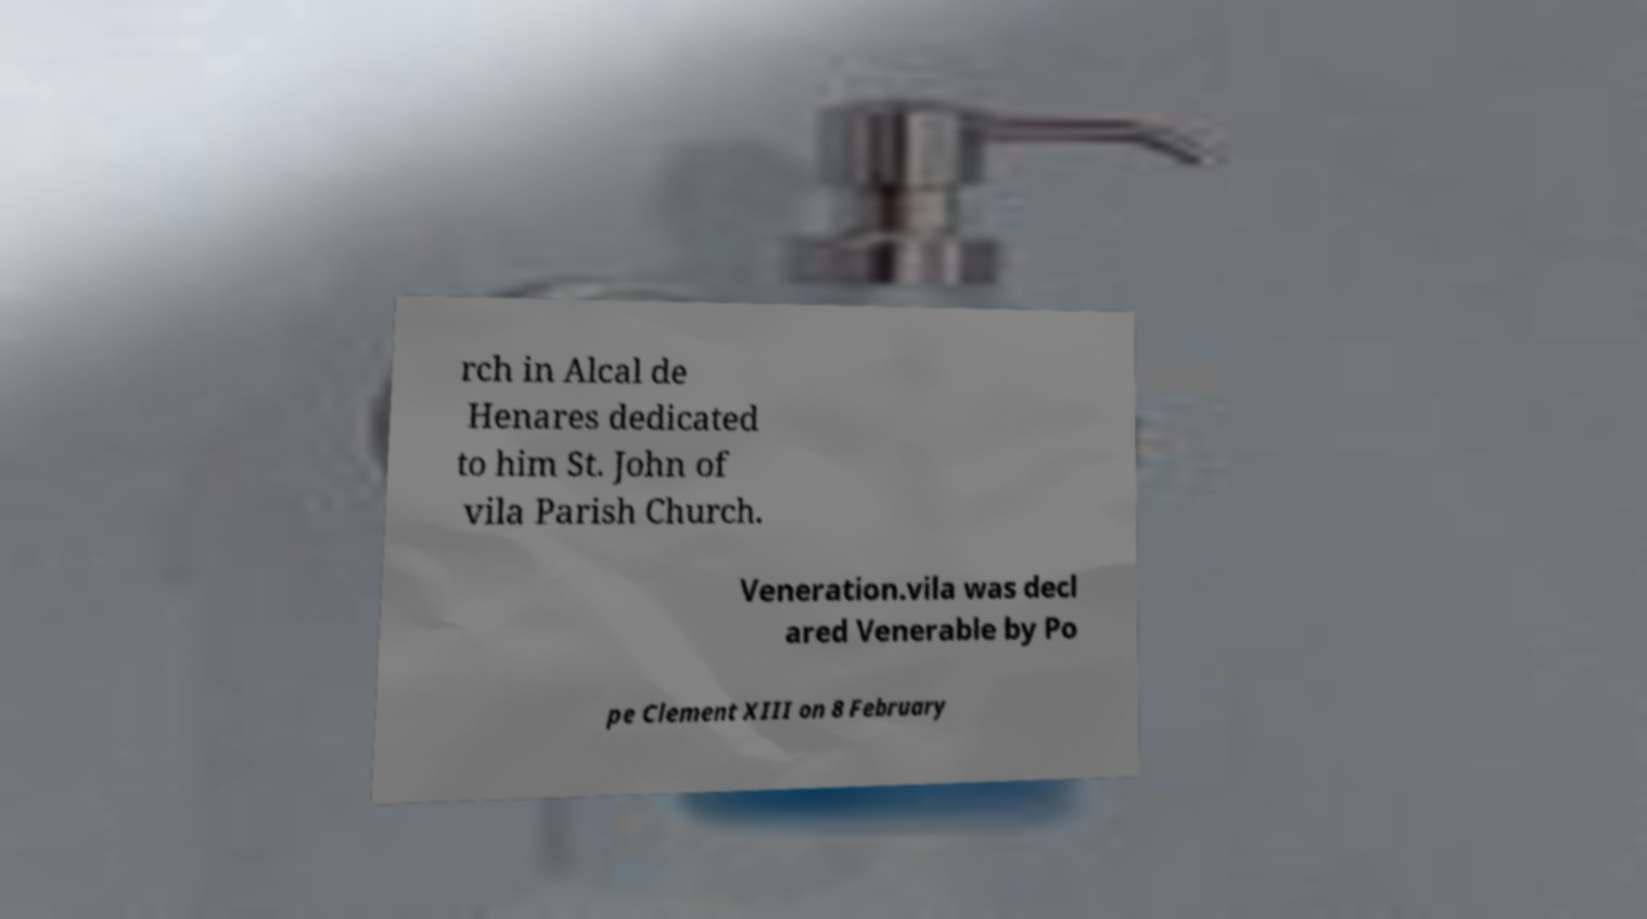Could you extract and type out the text from this image? rch in Alcal de Henares dedicated to him St. John of vila Parish Church. Veneration.vila was decl ared Venerable by Po pe Clement XIII on 8 February 